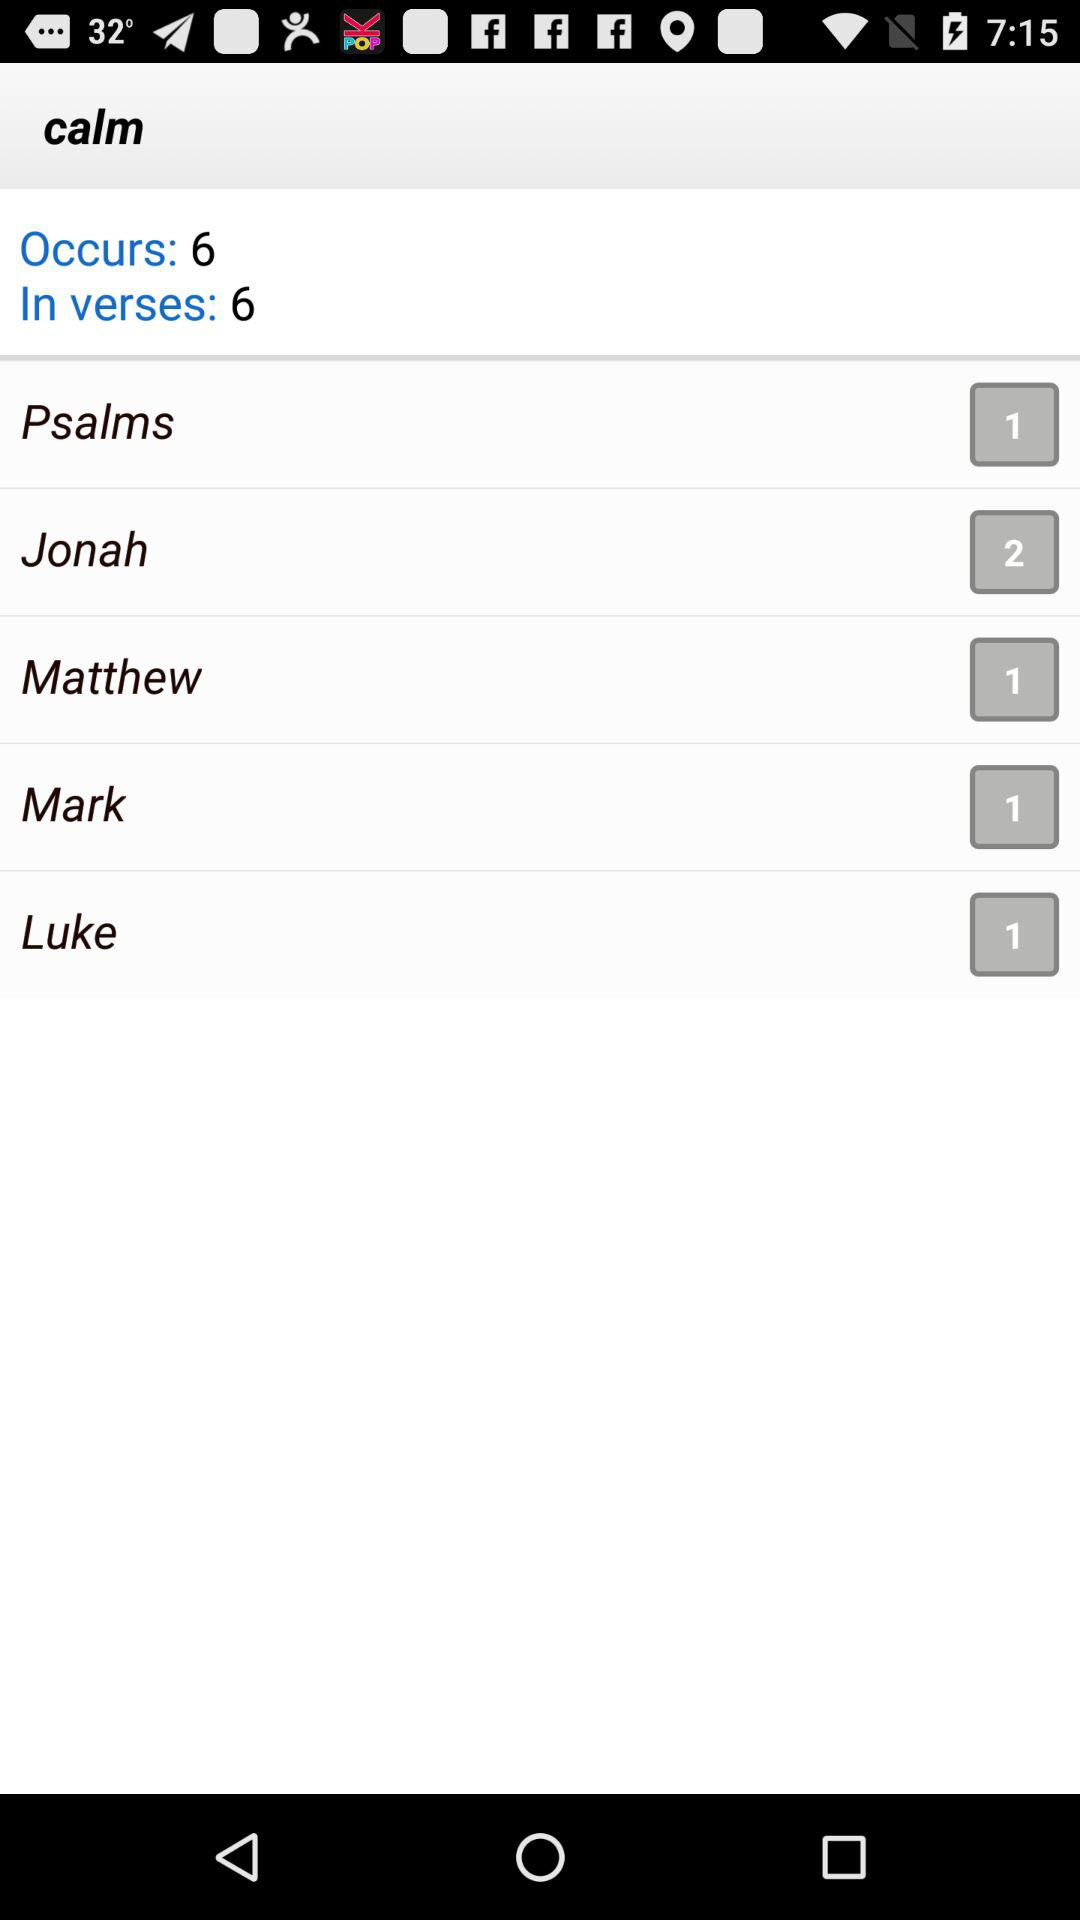What is the number for Mark? The number for Mark is 1. 